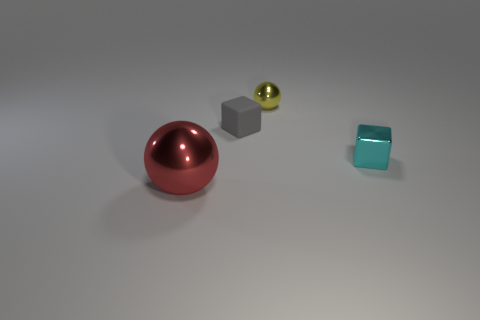Add 1 small purple spheres. How many objects exist? 5 Subtract 2 cubes. How many cubes are left? 0 Subtract all gray cubes. Subtract all brown balls. How many cubes are left? 1 Subtract all red spheres. How many red blocks are left? 0 Subtract all small shiny balls. Subtract all big blue things. How many objects are left? 3 Add 2 small cyan metallic cubes. How many small cyan metallic cubes are left? 3 Add 4 rubber blocks. How many rubber blocks exist? 5 Subtract all cyan blocks. How many blocks are left? 1 Subtract 0 gray balls. How many objects are left? 4 